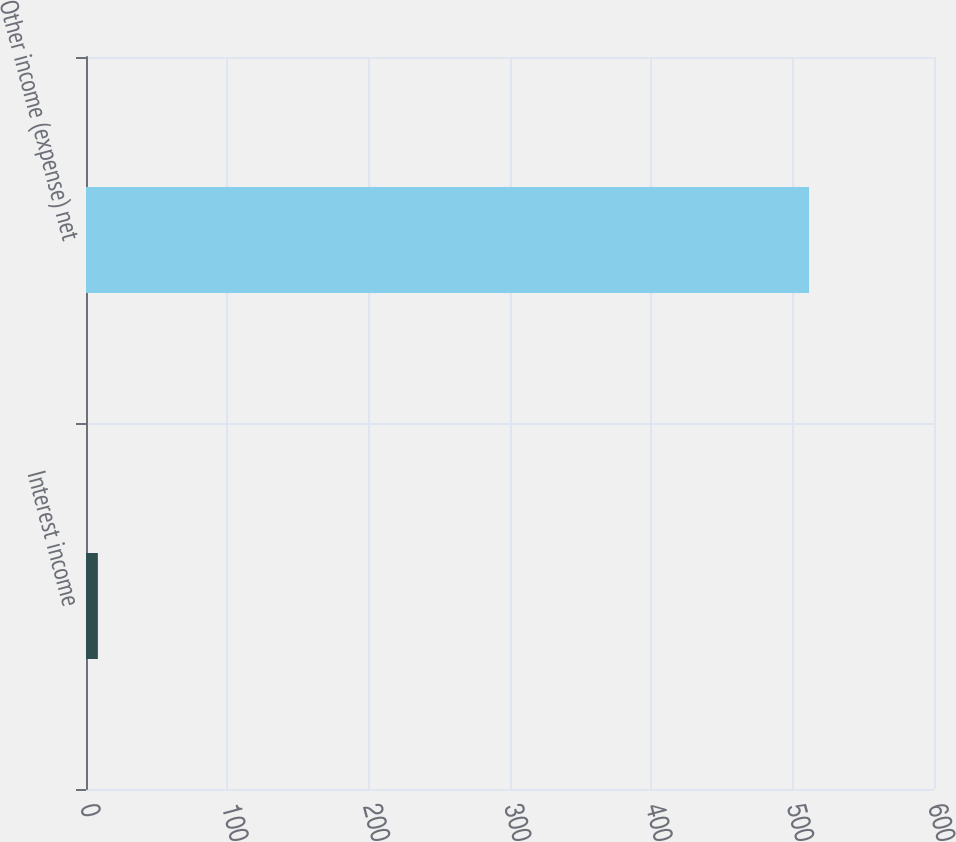Convert chart to OTSL. <chart><loc_0><loc_0><loc_500><loc_500><bar_chart><fcel>Interest income<fcel>Other income (expense) net<nl><fcel>8.4<fcel>511.6<nl></chart> 